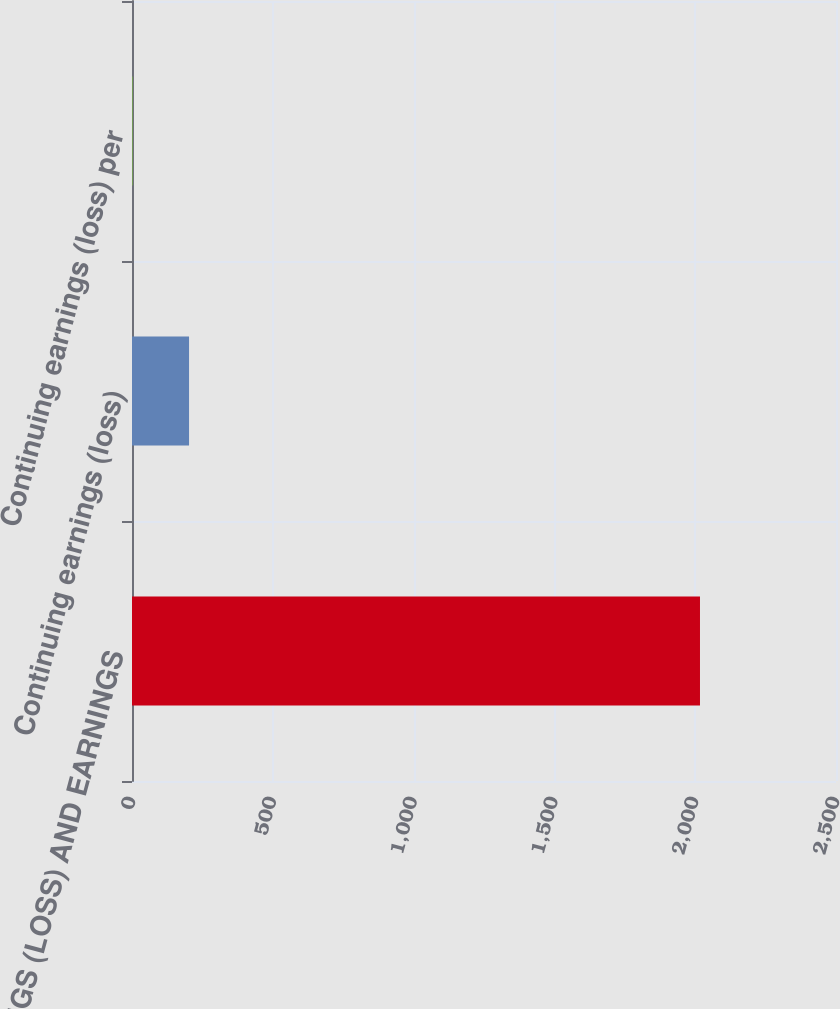Convert chart. <chart><loc_0><loc_0><loc_500><loc_500><bar_chart><fcel>EARNINGS (LOSS) AND EARNINGS<fcel>Continuing earnings (loss)<fcel>Continuing earnings (loss) per<nl><fcel>2017<fcel>202.59<fcel>0.99<nl></chart> 